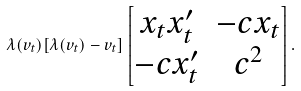Convert formula to latex. <formula><loc_0><loc_0><loc_500><loc_500>\lambda ( v _ { t } ) [ \lambda ( v _ { t } ) - v _ { t } ] \begin{bmatrix} x _ { t } x ^ { \prime } _ { t } & - c x _ { t } \\ - c x ^ { \prime } _ { t } & c ^ { 2 } \end{bmatrix} .</formula> 